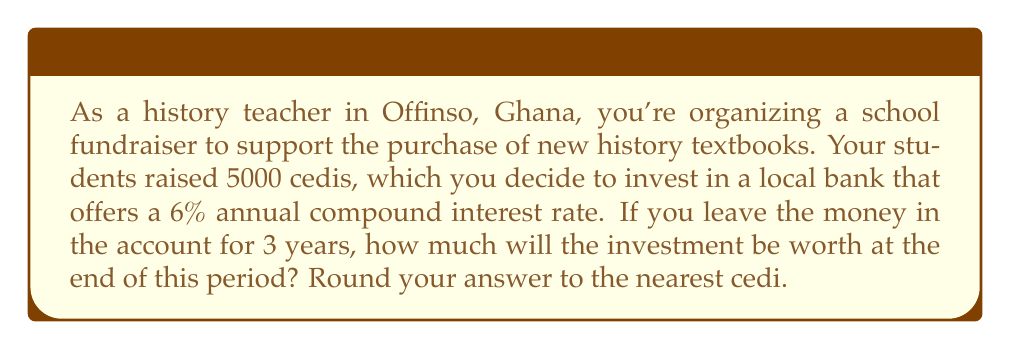Help me with this question. To solve this problem, we'll use the compound interest formula:

$$A = P(1 + r)^n$$

Where:
$A$ = Final amount
$P$ = Principal (initial investment)
$r$ = Annual interest rate (in decimal form)
$n$ = Number of years

Given:
$P = 5000$ cedis
$r = 6\% = 0.06$
$n = 3$ years

Let's substitute these values into the formula:

$$A = 5000(1 + 0.06)^3$$

Now, let's calculate step by step:

1) First, calculate $(1 + 0.06)^3$:
   $$(1.06)^3 = 1.06 \times 1.06 \times 1.06 = 1.191016$$

2) Now multiply this by the principal:
   $$5000 \times 1.191016 = 5955.08$$

3) Rounding to the nearest cedi:
   $$5955.08 \approx 5955$$ cedis

Therefore, after 3 years, the investment will be worth 5955 cedis.
Answer: 5955 cedis 